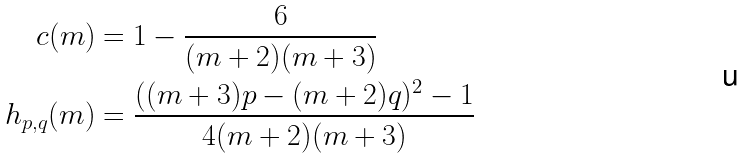Convert formula to latex. <formula><loc_0><loc_0><loc_500><loc_500>c ( m ) & = 1 - \frac { 6 } { ( m + 2 ) ( m + 3 ) } \\ h _ { p , q } ( m ) & = \frac { ( ( m + 3 ) p - ( m + 2 ) q ) ^ { 2 } - 1 } { 4 ( m + 2 ) ( m + 3 ) }</formula> 